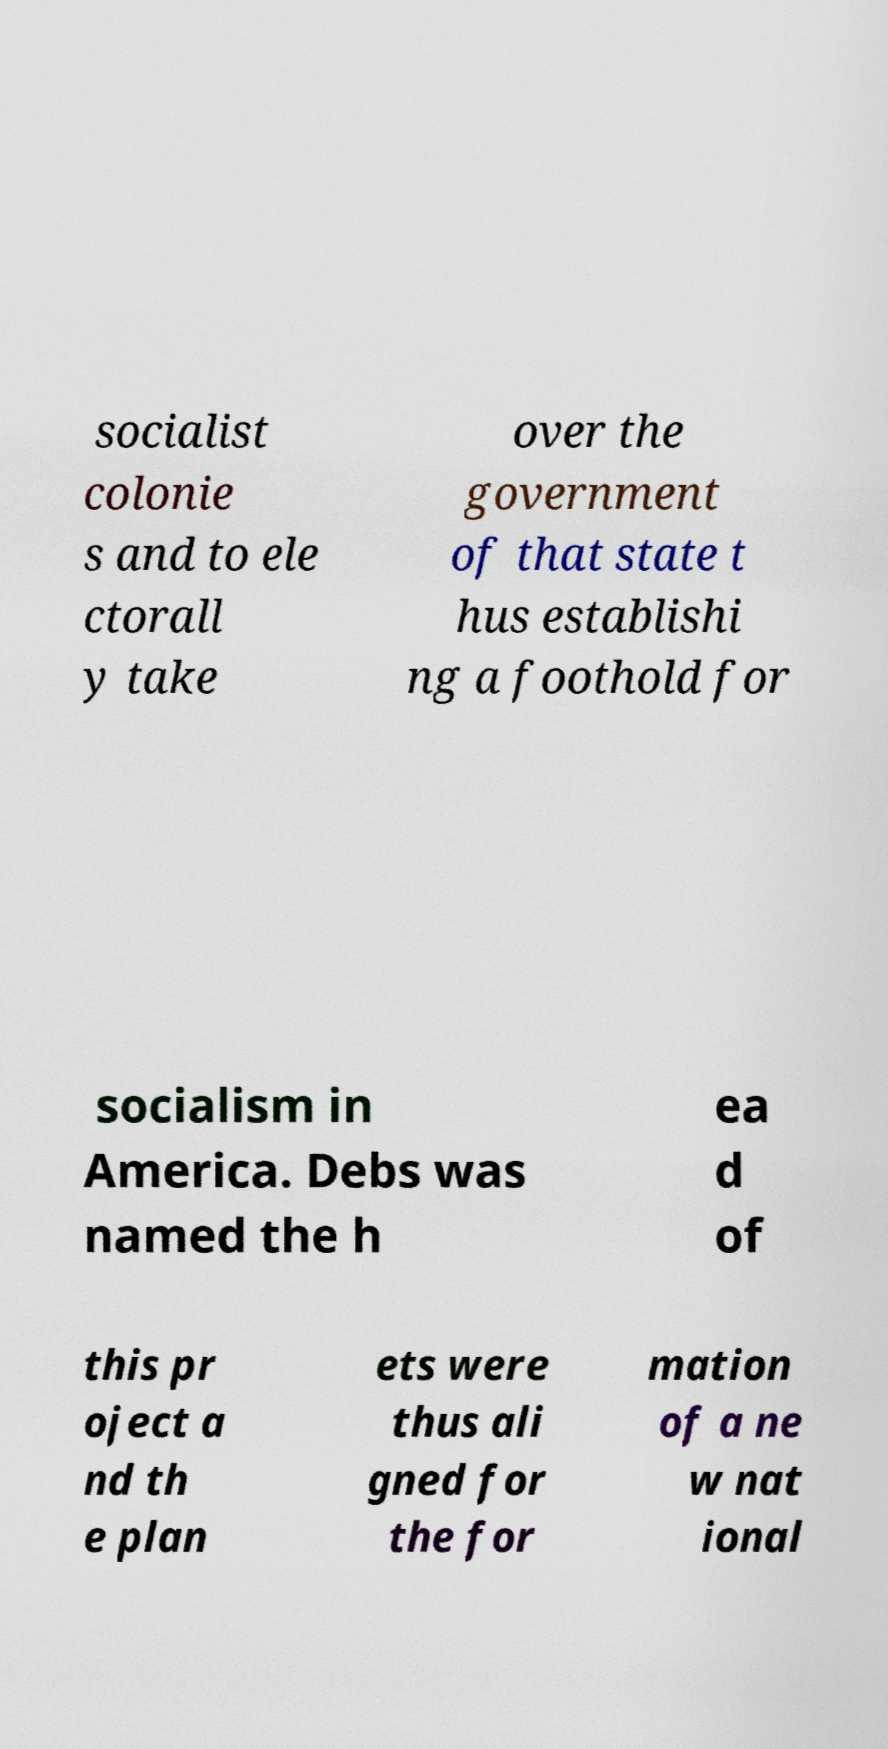Please read and relay the text visible in this image. What does it say? socialist colonie s and to ele ctorall y take over the government of that state t hus establishi ng a foothold for socialism in America. Debs was named the h ea d of this pr oject a nd th e plan ets were thus ali gned for the for mation of a ne w nat ional 